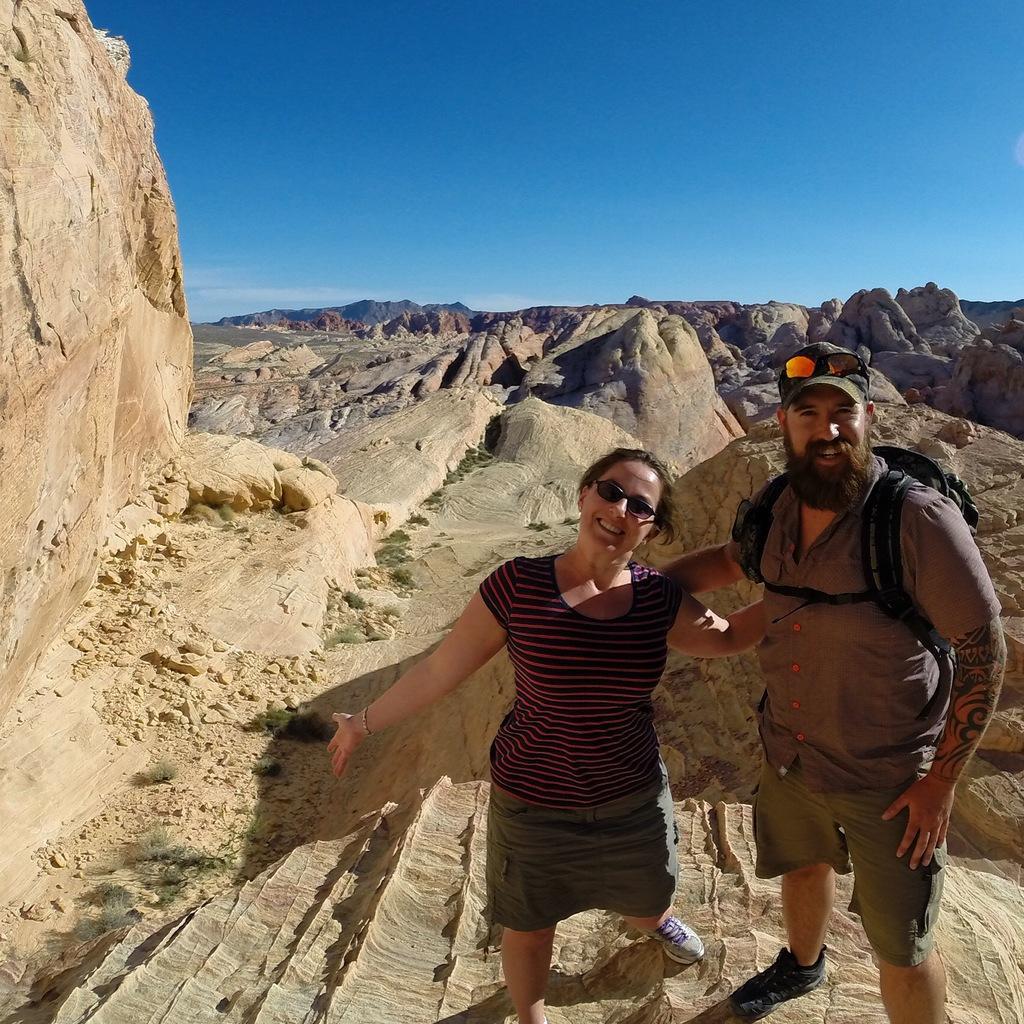In one or two sentences, can you explain what this image depicts? In this image, we can see a woman and man standing and smiling. A man wearing a backpack. We can see rocks, stones and plants. In the background, we can see rocks and the sky. 